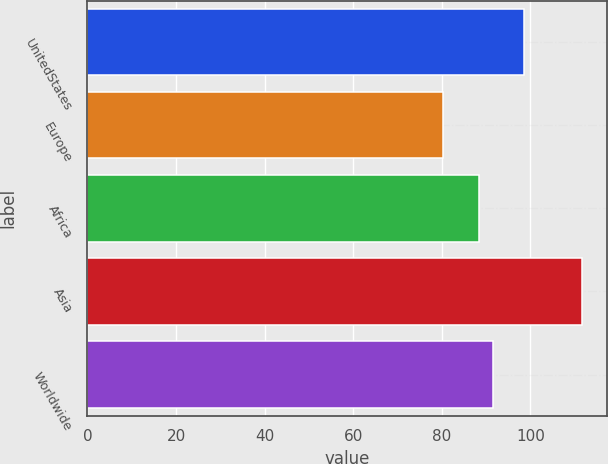Convert chart to OTSL. <chart><loc_0><loc_0><loc_500><loc_500><bar_chart><fcel>UnitedStates<fcel>Europe<fcel>Africa<fcel>Asia<fcel>Worldwide<nl><fcel>98.56<fcel>80.18<fcel>88.46<fcel>111.71<fcel>91.61<nl></chart> 